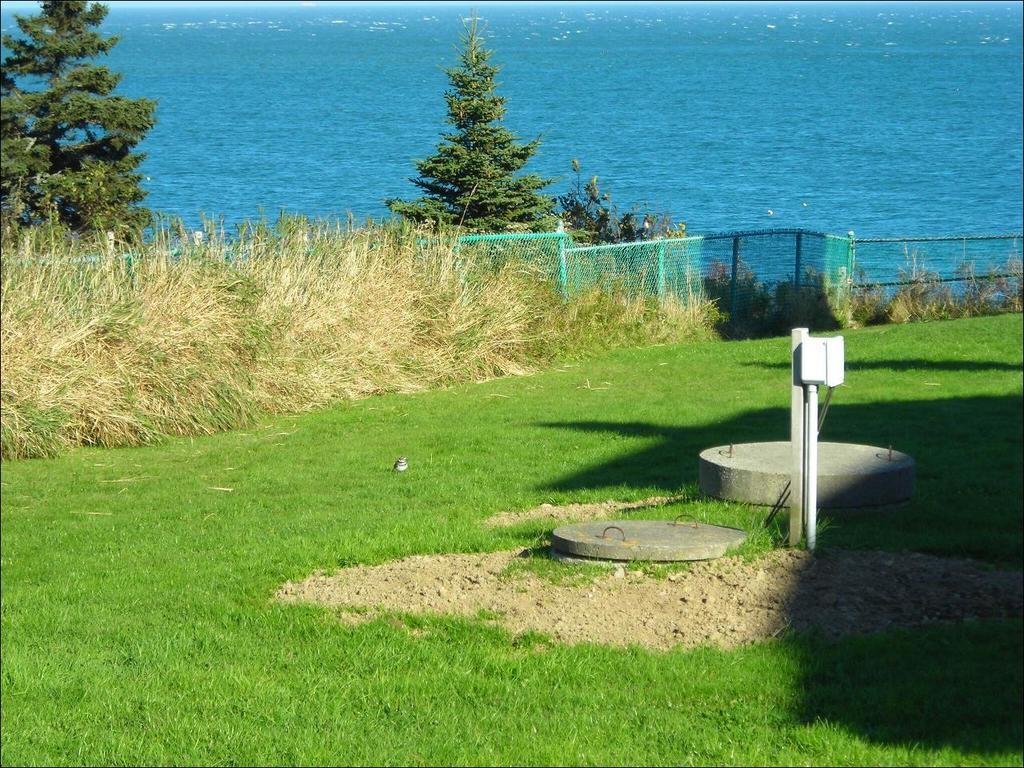In one or two sentences, can you explain what this image depicts? In this picture we can see the grass, fence, pole, concrete lids, trees and some objects and in the background we can see the water. 